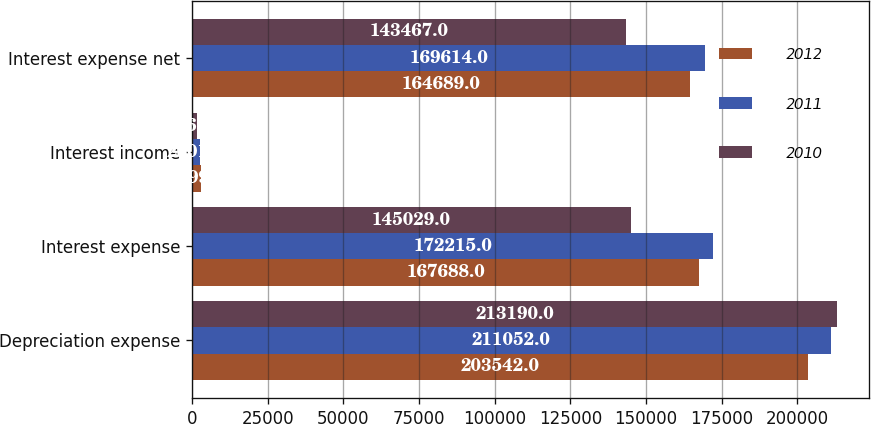Convert chart. <chart><loc_0><loc_0><loc_500><loc_500><stacked_bar_chart><ecel><fcel>Depreciation expense<fcel>Interest expense<fcel>Interest income<fcel>Interest expense net<nl><fcel>2012<fcel>203542<fcel>167688<fcel>2999<fcel>164689<nl><fcel>2011<fcel>211052<fcel>172215<fcel>2601<fcel>169614<nl><fcel>2010<fcel>213190<fcel>145029<fcel>1562<fcel>143467<nl></chart> 